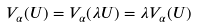<formula> <loc_0><loc_0><loc_500><loc_500>V _ { \alpha } ( U ) = V _ { \alpha } ( \lambda U ) = \lambda V _ { \alpha } ( U )</formula> 